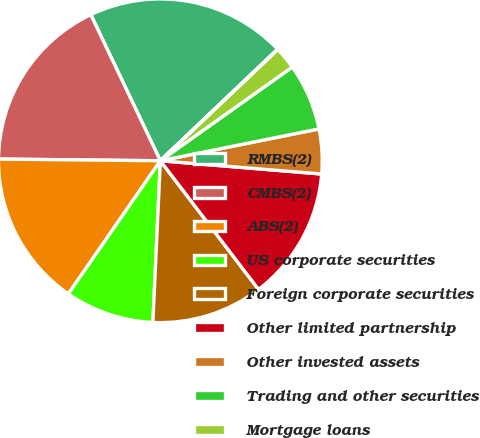Convert chart. <chart><loc_0><loc_0><loc_500><loc_500><pie_chart><fcel>RMBS(2)<fcel>CMBS(2)<fcel>ABS(2)<fcel>US corporate securities<fcel>Foreign corporate securities<fcel>Other limited partnership<fcel>Other invested assets<fcel>Trading and other securities<fcel>Mortgage loans<fcel>Real estate joint ventures<nl><fcel>19.97%<fcel>17.76%<fcel>15.54%<fcel>8.89%<fcel>11.11%<fcel>13.32%<fcel>4.46%<fcel>6.68%<fcel>2.24%<fcel>0.03%<nl></chart> 